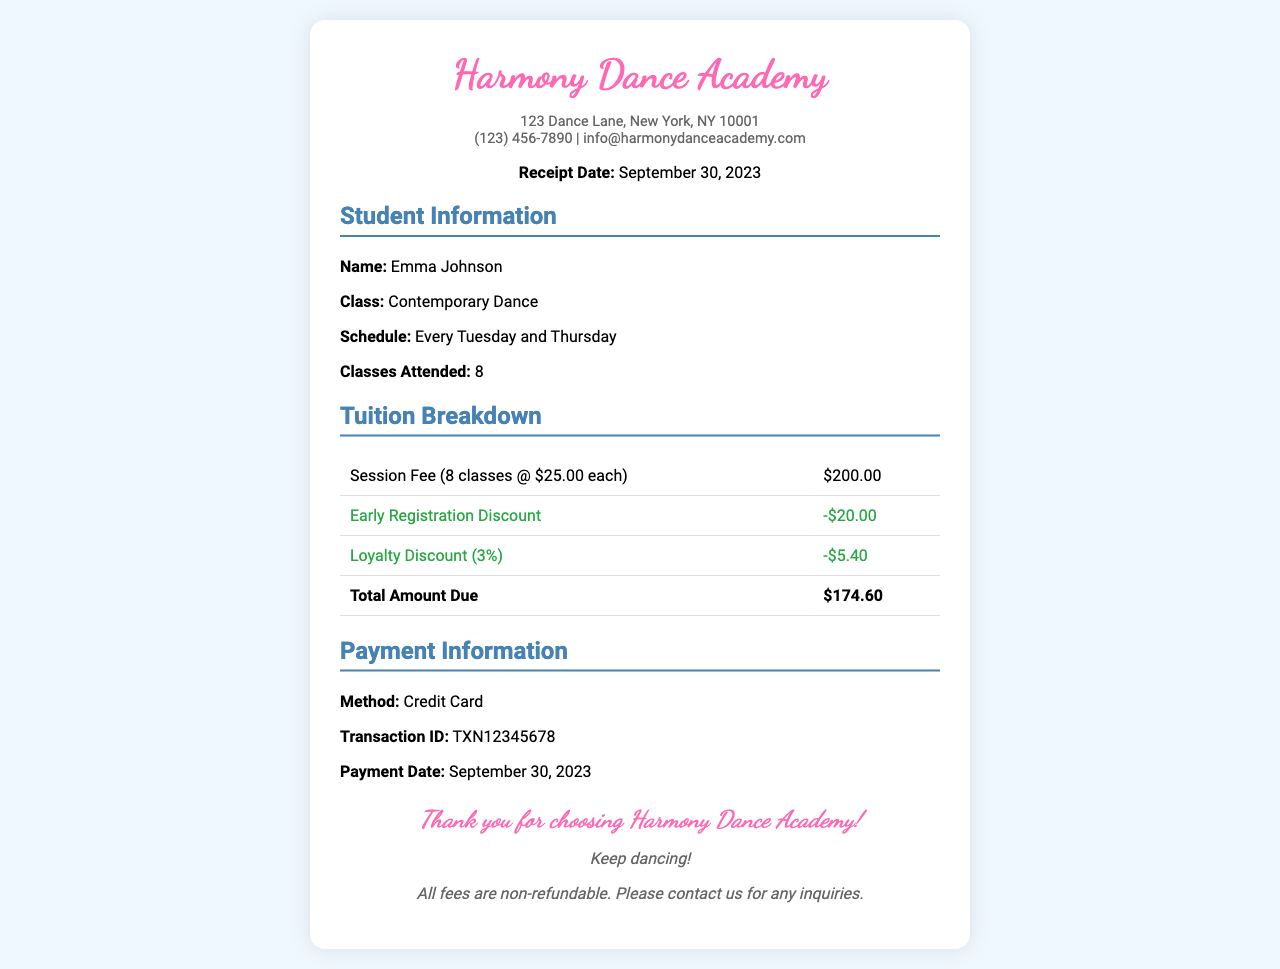what is the name of the dance academy? The document states that the name of the dance academy is Harmony Dance Academy.
Answer: Harmony Dance Academy what is the date of the receipt? The receipt date is clearly mentioned as September 30, 2023.
Answer: September 30, 2023 how many classes did Emma Johnson attend? The document specifies that Emma attended a total of 8 classes.
Answer: 8 what is the amount of the early registration discount? The early registration discount applied is indicated as -$20.00.
Answer: -$20.00 what was the session fee for the classes? The document lists the session fee for the classes as $200.00 (for 8 classes).
Answer: $200.00 what percentage is the loyalty discount? The loyalty discount percentage mentioned in the document is 3%.
Answer: 3% what is the total amount due? The receipt explicitly states that the total amount due is $174.60 after discounts.
Answer: $174.60 what payment method was used? The payment information section indicates that the method used was a credit card.
Answer: Credit Card what is the transaction ID? The document provides the transaction ID as TXN12345678.
Answer: TXN12345678 